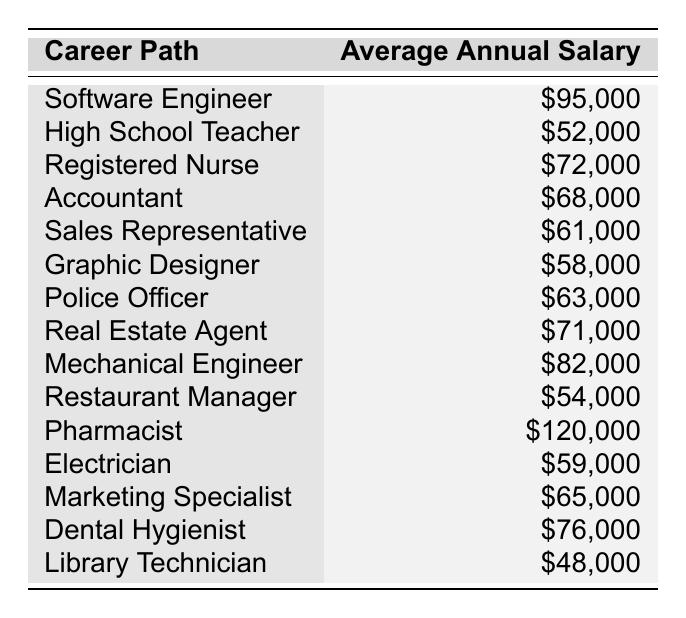What is the average annual salary of a Software Engineer? The table lists the salary of a Software Engineer as $95,000 directly in the "Average Annual Salary" column next to that career path.
Answer: $95,000 Which career path has the lowest average annual salary? By reviewing the table, the "Library Technician" has the lowest average annual salary of $48,000, as it is the smallest number listed.
Answer: $48,000 How much more does a Pharmacist earn compared to a High School Teacher? The salary of a Pharmacist is $120,000, and the salary of a High School Teacher is $52,000. To find the difference, subtract $52,000 from $120,000: $120,000 - $52,000 = $68,000.
Answer: $68,000 What is the average annual salary of the top three highest-paid career paths? The top three highest-paid salaries are from Pharmacist ($120,000), Software Engineer ($95,000), and Mechanical Engineer ($82,000). To find the average, sum these values: $120,000 + $95,000 + $82,000 = $297,000, then divide by 3: $297,000 / 3 = $99,000.
Answer: $99,000 Is the average annual salary of a Dental Hygienist greater than $70,000? The salary for a Dental Hygienist is $76,000, which is greater than $70,000, confirming that the statement is true.
Answer: Yes What is the total salary of all the careers listed in the table? The total salary can be calculated by summing each career's salary: $95,000 + $52,000 + $72,000 + $68,000 + $61,000 + $58,000 + $63,000 + $71,000 + $82,000 + $54,000 + $120,000 + $59,000 + $65,000 + $76,000 + $48,000 = $1,077,000.
Answer: $1,077,000 Which career path earns exactly $68,000? The table shows that the Accountant's average annual salary is exactly $68,000.
Answer: Accountant What percentage more does a Registered Nurse earn than a Restaurant Manager? The Registered Nurse earns $72,000 and the Restaurant Manager earns $54,000. To find the percentage increase: ($72,000 - $54,000) / $54,000 * 100 = 33.33%.
Answer: 33.33% Are there more career paths listed with an average salary greater than $70,000 or less than $50,000? Four career paths earn more than $70,000 (Pharmacist, Software Engineer, Mechanical Engineer, and Dental Hygienist), while one career path earns less than $50,000 (Library Technician), so there are more paths earning above $70,000.
Answer: More than $70,000 Which career has the second highest salary? The salaries in descending order show that the second highest salary is $95,000, which belongs to a Software Engineer, after the Pharmacist's $120,000.
Answer: Software Engineer 